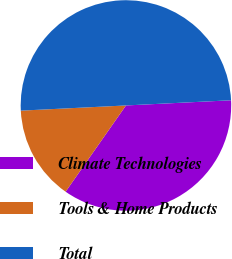Convert chart. <chart><loc_0><loc_0><loc_500><loc_500><pie_chart><fcel>Climate Technologies<fcel>Tools & Home Products<fcel>Total<nl><fcel>35.5%<fcel>14.5%<fcel>50.0%<nl></chart> 